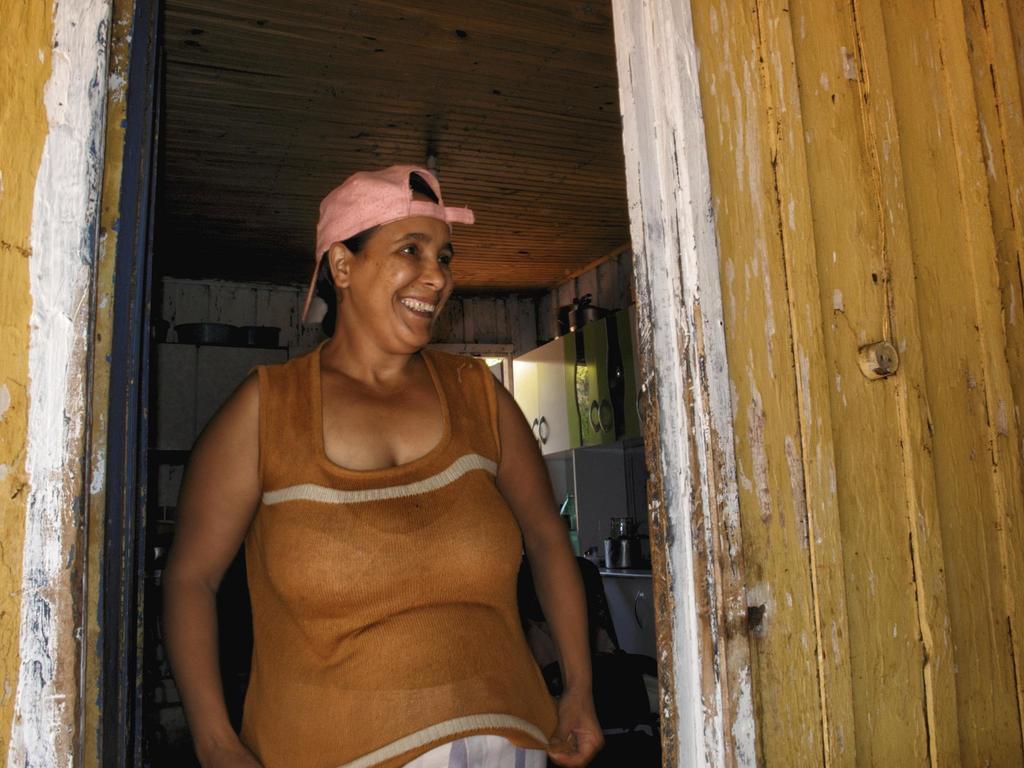Describe this image in one or two sentences. The woman in brown t-shirt who is wearing a pink cap is standing in the middle of the picture and she is smiling. Beside her, we see a wall which is in yellow color. Behind her, there is a white wall and a cupboard. We even see a chair and a table on which bottles are placed. At the top of the picture, we see the ceiling of that room. 